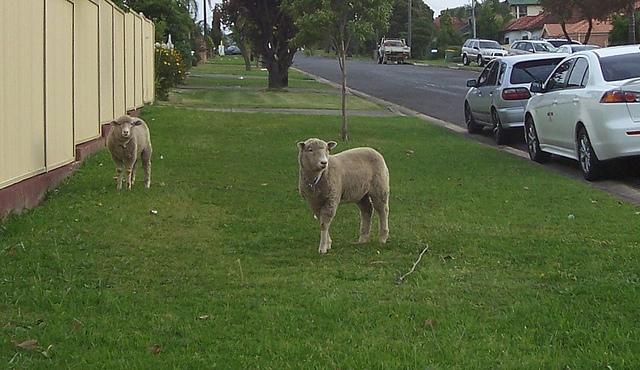How many cars can be seen?
Write a very short answer. 7. What color are the cars in the picture?
Be succinct. White. Are the sheep in a fenced in area?
Short answer required. No. Are the sheep running?
Be succinct. No. Are those baby lambs?
Short answer required. Yes. 